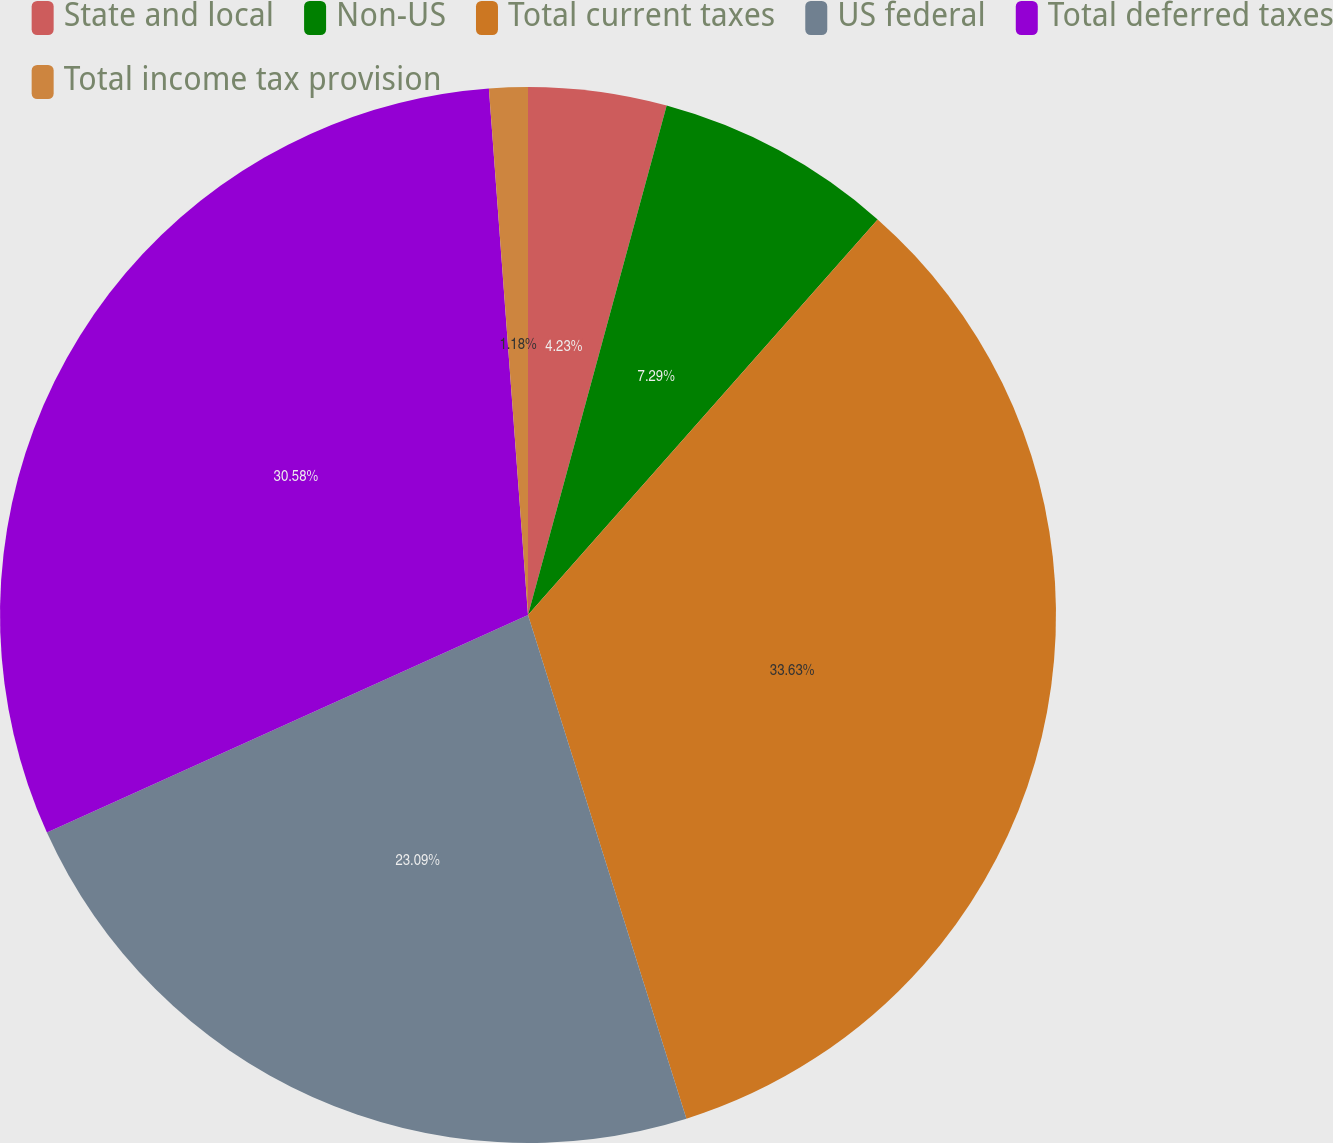Convert chart. <chart><loc_0><loc_0><loc_500><loc_500><pie_chart><fcel>State and local<fcel>Non-US<fcel>Total current taxes<fcel>US federal<fcel>Total deferred taxes<fcel>Total income tax provision<nl><fcel>4.23%<fcel>7.29%<fcel>33.63%<fcel>23.09%<fcel>30.58%<fcel>1.18%<nl></chart> 